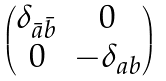Convert formula to latex. <formula><loc_0><loc_0><loc_500><loc_500>\begin{pmatrix} \delta _ { \bar { a } \bar { b } } & 0 \\ 0 & - \delta _ { a b } \end{pmatrix}</formula> 